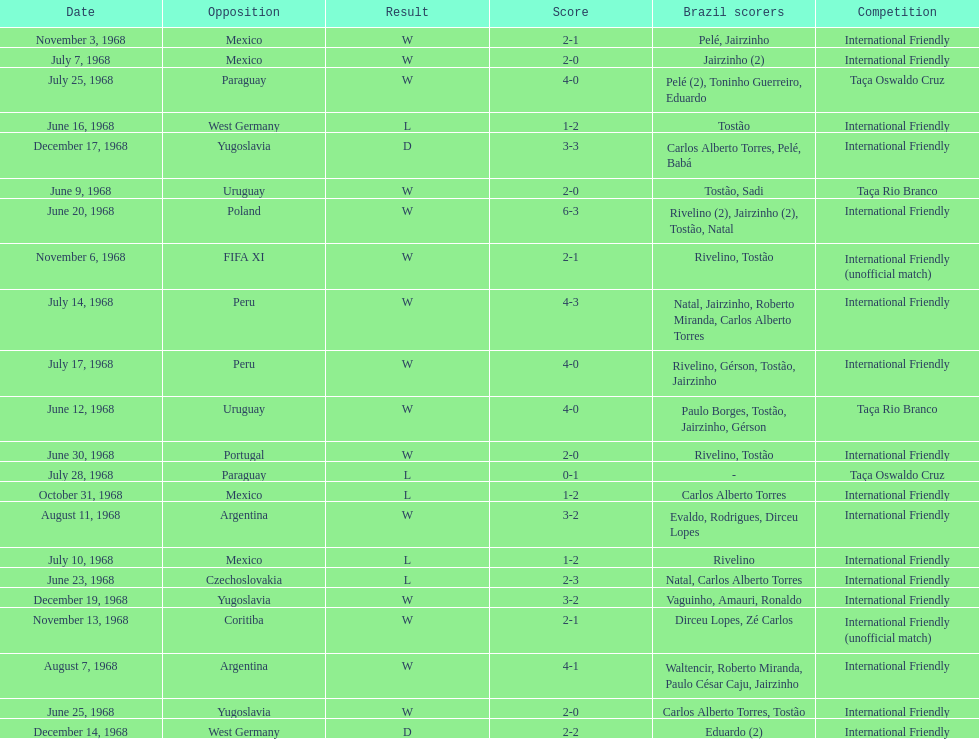What is the top score ever scored by the brazil national team? 6. Write the full table. {'header': ['Date', 'Opposition', 'Result', 'Score', 'Brazil scorers', 'Competition'], 'rows': [['November 3, 1968', 'Mexico', 'W', '2-1', 'Pelé, Jairzinho', 'International Friendly'], ['July 7, 1968', 'Mexico', 'W', '2-0', 'Jairzinho (2)', 'International Friendly'], ['July 25, 1968', 'Paraguay', 'W', '4-0', 'Pelé (2), Toninho Guerreiro, Eduardo', 'Taça Oswaldo Cruz'], ['June 16, 1968', 'West Germany', 'L', '1-2', 'Tostão', 'International Friendly'], ['December 17, 1968', 'Yugoslavia', 'D', '3-3', 'Carlos Alberto Torres, Pelé, Babá', 'International Friendly'], ['June 9, 1968', 'Uruguay', 'W', '2-0', 'Tostão, Sadi', 'Taça Rio Branco'], ['June 20, 1968', 'Poland', 'W', '6-3', 'Rivelino (2), Jairzinho (2), Tostão, Natal', 'International Friendly'], ['November 6, 1968', 'FIFA XI', 'W', '2-1', 'Rivelino, Tostão', 'International Friendly (unofficial match)'], ['July 14, 1968', 'Peru', 'W', '4-3', 'Natal, Jairzinho, Roberto Miranda, Carlos Alberto Torres', 'International Friendly'], ['July 17, 1968', 'Peru', 'W', '4-0', 'Rivelino, Gérson, Tostão, Jairzinho', 'International Friendly'], ['June 12, 1968', 'Uruguay', 'W', '4-0', 'Paulo Borges, Tostão, Jairzinho, Gérson', 'Taça Rio Branco'], ['June 30, 1968', 'Portugal', 'W', '2-0', 'Rivelino, Tostão', 'International Friendly'], ['July 28, 1968', 'Paraguay', 'L', '0-1', '-', 'Taça Oswaldo Cruz'], ['October 31, 1968', 'Mexico', 'L', '1-2', 'Carlos Alberto Torres', 'International Friendly'], ['August 11, 1968', 'Argentina', 'W', '3-2', 'Evaldo, Rodrigues, Dirceu Lopes', 'International Friendly'], ['July 10, 1968', 'Mexico', 'L', '1-2', 'Rivelino', 'International Friendly'], ['June 23, 1968', 'Czechoslovakia', 'L', '2-3', 'Natal, Carlos Alberto Torres', 'International Friendly'], ['December 19, 1968', 'Yugoslavia', 'W', '3-2', 'Vaguinho, Amauri, Ronaldo', 'International Friendly'], ['November 13, 1968', 'Coritiba', 'W', '2-1', 'Dirceu Lopes, Zé Carlos', 'International Friendly (unofficial match)'], ['August 7, 1968', 'Argentina', 'W', '4-1', 'Waltencir, Roberto Miranda, Paulo César Caju, Jairzinho', 'International Friendly'], ['June 25, 1968', 'Yugoslavia', 'W', '2-0', 'Carlos Alberto Torres, Tostão', 'International Friendly'], ['December 14, 1968', 'West Germany', 'D', '2-2', 'Eduardo (2)', 'International Friendly']]} 